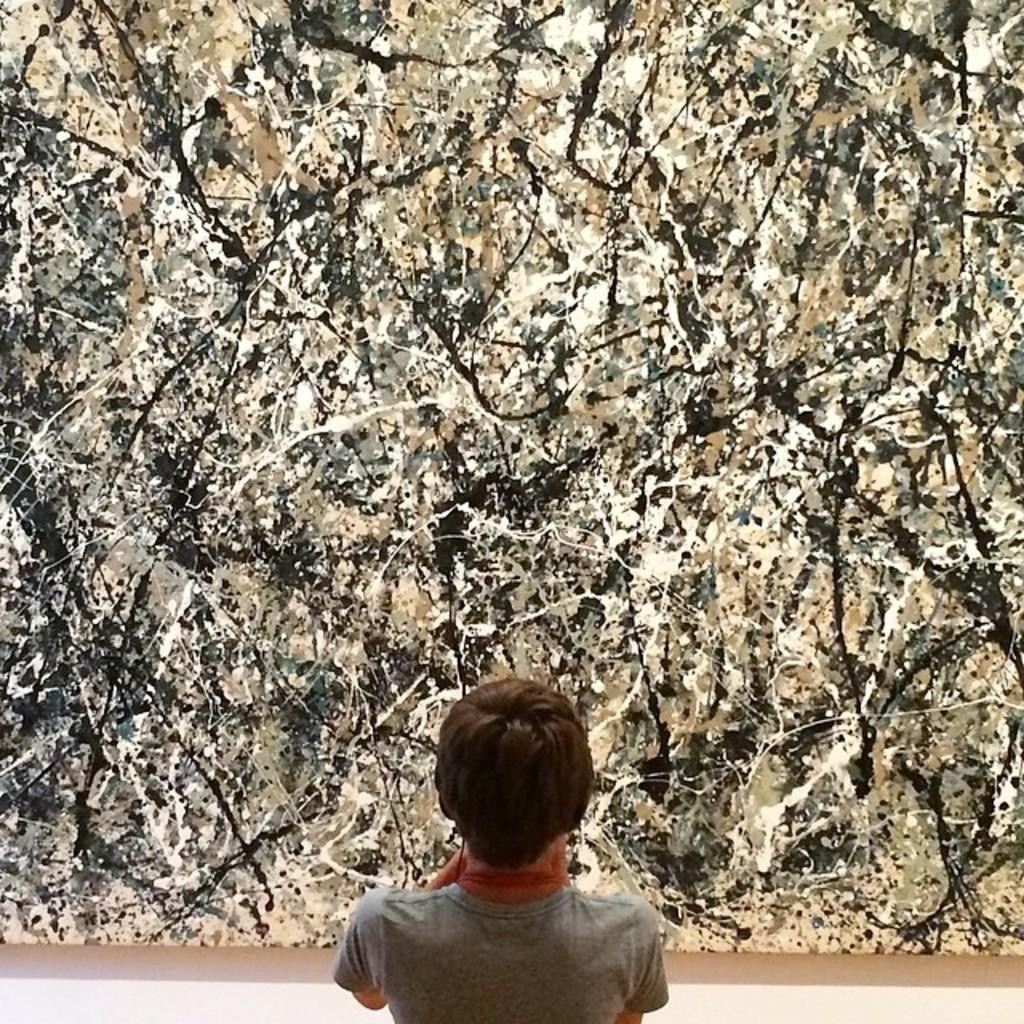Who or what is depicted in the image? There is a person in the image. What is the person wearing? The person is wearing clothes. What type of artwork is the image? The image is a painting. What type of cushion is the person sitting on in the park? There is no cushion or park present in the image; it is a painting of a person wearing clothes. 